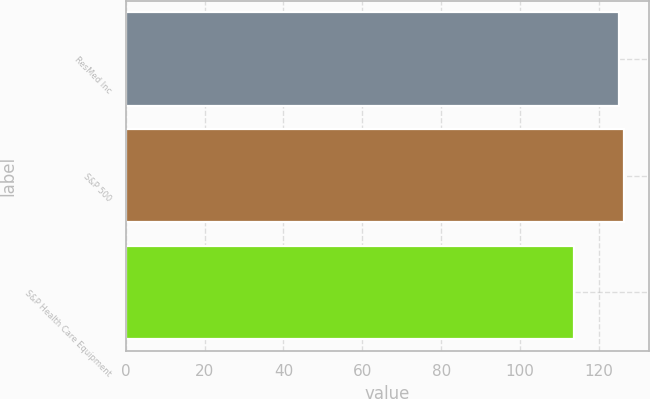Convert chart. <chart><loc_0><loc_0><loc_500><loc_500><bar_chart><fcel>ResMed Inc<fcel>S&P 500<fcel>S&P Health Care Equipment<nl><fcel>125<fcel>126.26<fcel>113.6<nl></chart> 